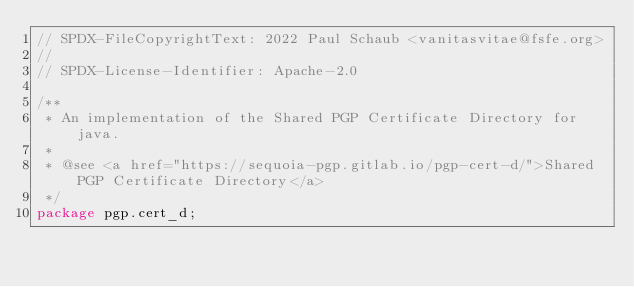Convert code to text. <code><loc_0><loc_0><loc_500><loc_500><_Java_>// SPDX-FileCopyrightText: 2022 Paul Schaub <vanitasvitae@fsfe.org>
//
// SPDX-License-Identifier: Apache-2.0

/**
 * An implementation of the Shared PGP Certificate Directory for java.
 *
 * @see <a href="https://sequoia-pgp.gitlab.io/pgp-cert-d/">Shared PGP Certificate Directory</a>
 */
package pgp.cert_d;
</code> 